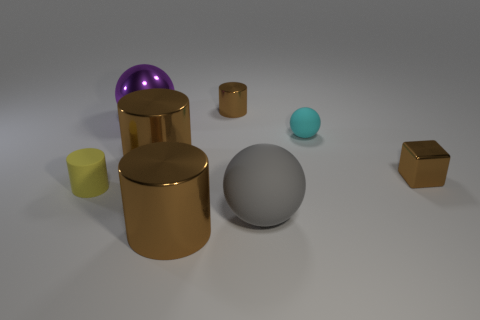How many brown cylinders must be subtracted to get 1 brown cylinders? 2 Subtract all small cyan matte spheres. How many spheres are left? 2 Subtract all purple spheres. How many spheres are left? 2 Subtract all spheres. How many objects are left? 5 Add 5 tiny yellow matte cylinders. How many tiny yellow matte cylinders exist? 6 Add 1 large gray matte spheres. How many objects exist? 9 Subtract 0 green cylinders. How many objects are left? 8 Subtract 2 cylinders. How many cylinders are left? 2 Subtract all red cylinders. Subtract all green balls. How many cylinders are left? 4 Subtract all cyan blocks. How many cyan cylinders are left? 0 